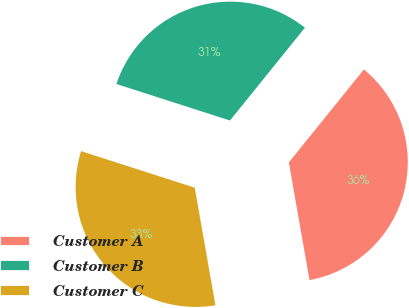Convert chart. <chart><loc_0><loc_0><loc_500><loc_500><pie_chart><fcel>Customer A<fcel>Customer B<fcel>Customer C<nl><fcel>36.42%<fcel>30.86%<fcel>32.72%<nl></chart> 